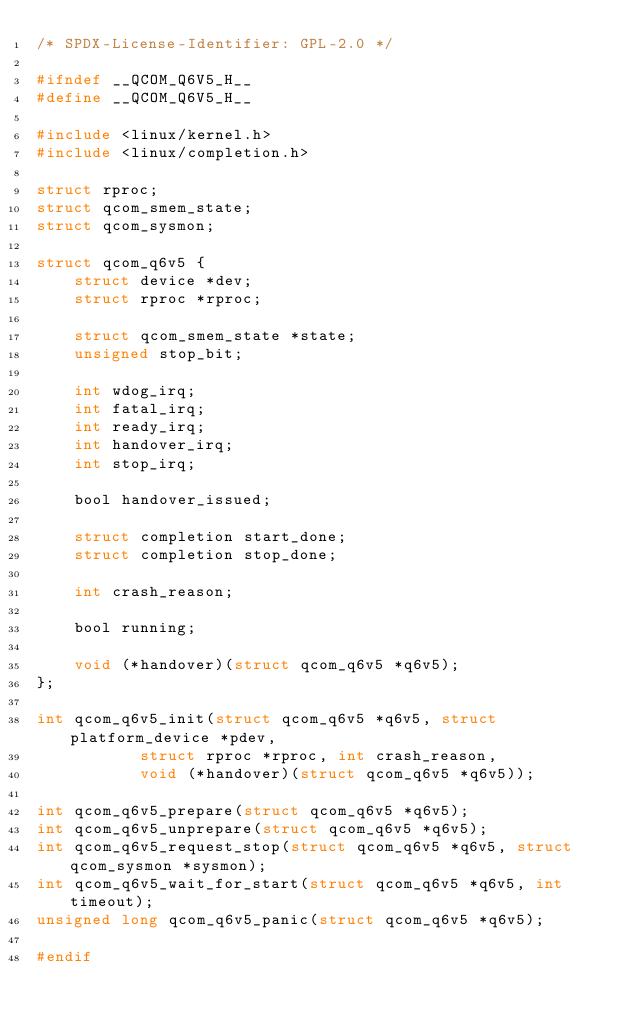<code> <loc_0><loc_0><loc_500><loc_500><_C_>/* SPDX-License-Identifier: GPL-2.0 */

#ifndef __QCOM_Q6V5_H__
#define __QCOM_Q6V5_H__

#include <linux/kernel.h>
#include <linux/completion.h>

struct rproc;
struct qcom_smem_state;
struct qcom_sysmon;

struct qcom_q6v5 {
	struct device *dev;
	struct rproc *rproc;

	struct qcom_smem_state *state;
	unsigned stop_bit;

	int wdog_irq;
	int fatal_irq;
	int ready_irq;
	int handover_irq;
	int stop_irq;

	bool handover_issued;

	struct completion start_done;
	struct completion stop_done;

	int crash_reason;

	bool running;

	void (*handover)(struct qcom_q6v5 *q6v5);
};

int qcom_q6v5_init(struct qcom_q6v5 *q6v5, struct platform_device *pdev,
		   struct rproc *rproc, int crash_reason,
		   void (*handover)(struct qcom_q6v5 *q6v5));

int qcom_q6v5_prepare(struct qcom_q6v5 *q6v5);
int qcom_q6v5_unprepare(struct qcom_q6v5 *q6v5);
int qcom_q6v5_request_stop(struct qcom_q6v5 *q6v5, struct qcom_sysmon *sysmon);
int qcom_q6v5_wait_for_start(struct qcom_q6v5 *q6v5, int timeout);
unsigned long qcom_q6v5_panic(struct qcom_q6v5 *q6v5);

#endif
</code> 